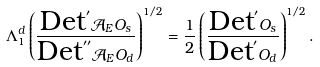<formula> <loc_0><loc_0><loc_500><loc_500>\Lambda _ { 1 } ^ { d } \left ( \frac { \text {Det} ^ { \prime } \mathcal { A } _ { E } O _ { s } } { \text {Det} ^ { \prime \prime } \mathcal { A } _ { E } O _ { d } } \right ) ^ { 1 / 2 } = \frac { 1 } { 2 } \left ( \frac { \text {Det} ^ { \prime } O _ { s } } { \text {Det} ^ { \prime } O _ { d } } \right ) ^ { 1 / 2 } .</formula> 